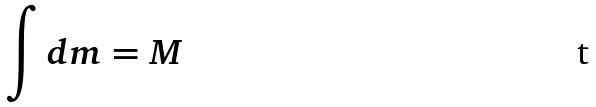Convert formula to latex. <formula><loc_0><loc_0><loc_500><loc_500>\int d m = M</formula> 